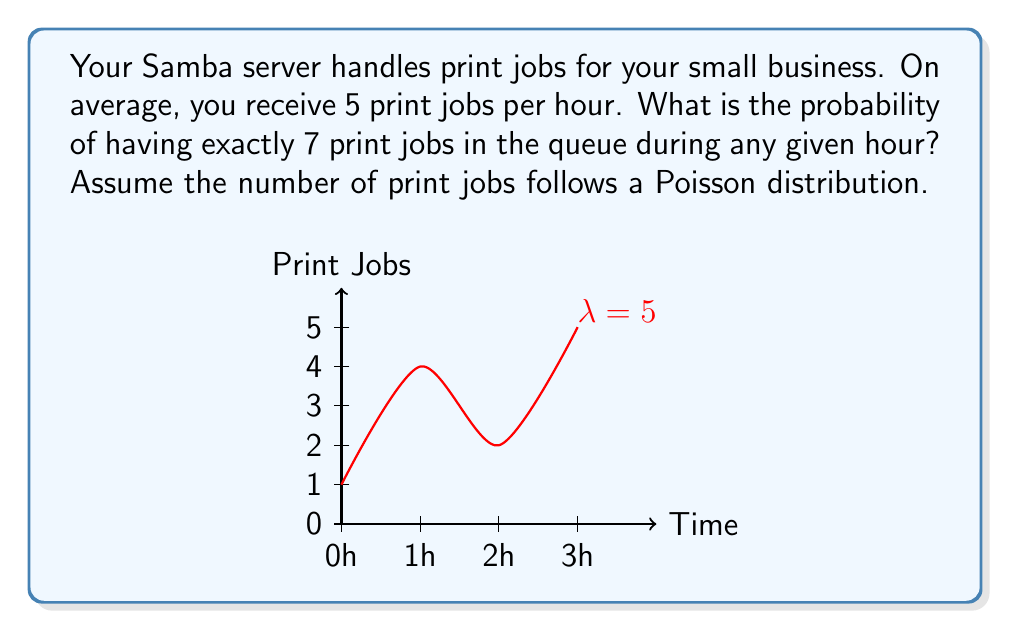Could you help me with this problem? To solve this problem, we'll use the Poisson distribution formula:

$$P(X = k) = \frac{e^{-\lambda} \lambda^k}{k!}$$

Where:
- $\lambda$ is the average number of events in the given interval
- $k$ is the number of events we're calculating the probability for
- $e$ is Euler's number (approximately 2.71828)

Given:
- $\lambda = 5$ (average of 5 print jobs per hour)
- $k = 7$ (we're calculating the probability of exactly 7 print jobs)

Step 1: Plug the values into the Poisson distribution formula:

$$P(X = 7) = \frac{e^{-5} 5^7}{7!}$$

Step 2: Calculate $5^7$:
$$5^7 = 78,125$$

Step 3: Calculate $7!$:
$$7! = 7 \times 6 \times 5 \times 4 \times 3 \times 2 \times 1 = 5,040$$

Step 4: Calculate $e^{-5}$:
$$e^{-5} \approx 0.00673795$$

Step 5: Put it all together:

$$P(X = 7) = \frac{0.00673795 \times 78,125}{5,040} \approx 0.1046$$

Therefore, the probability of having exactly 7 print jobs in the queue during any given hour is approximately 0.1046 or 10.46%.
Answer: $0.1046$ or $10.46\%$ 